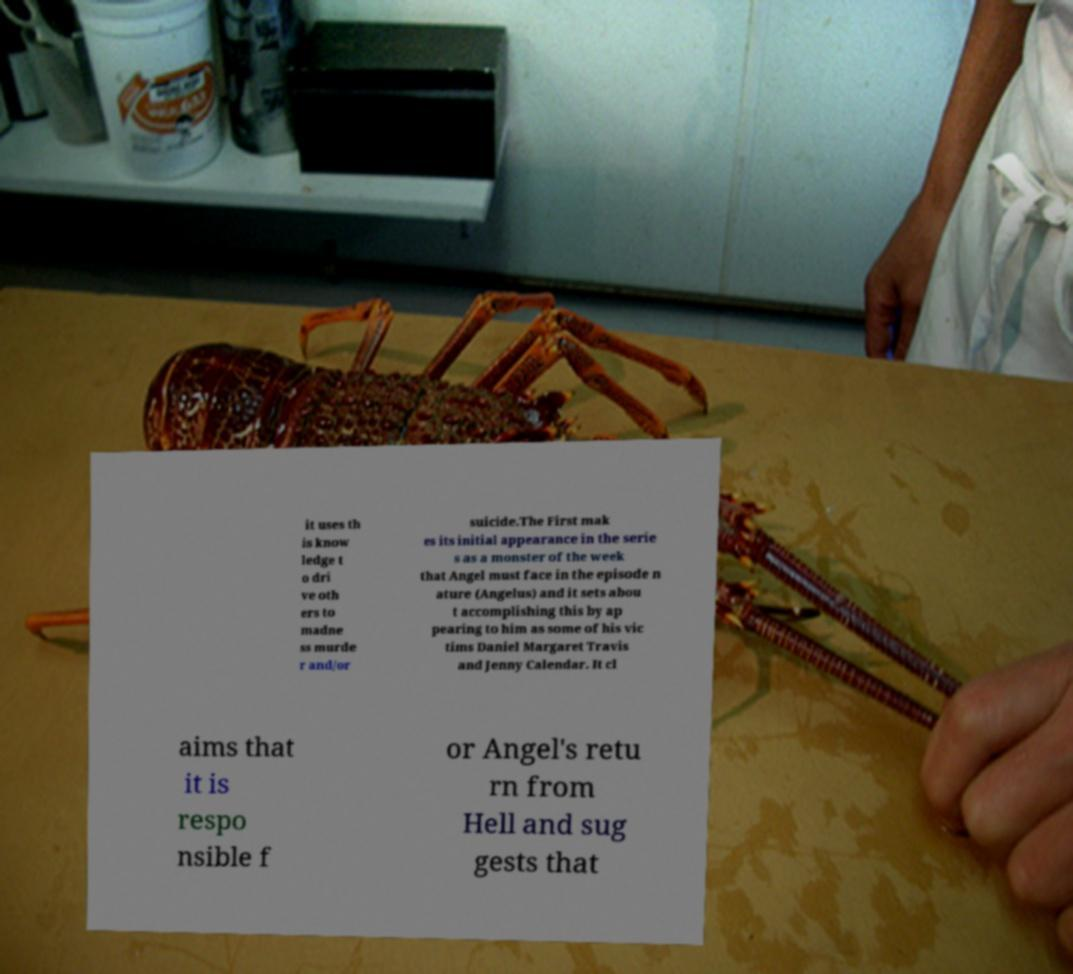What messages or text are displayed in this image? I need them in a readable, typed format. it uses th is know ledge t o dri ve oth ers to madne ss murde r and/or suicide.The First mak es its initial appearance in the serie s as a monster of the week that Angel must face in the episode n ature (Angelus) and it sets abou t accomplishing this by ap pearing to him as some of his vic tims Daniel Margaret Travis and Jenny Calendar. It cl aims that it is respo nsible f or Angel's retu rn from Hell and sug gests that 